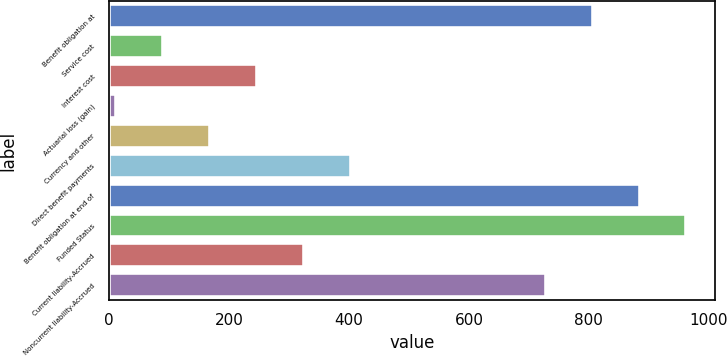Convert chart. <chart><loc_0><loc_0><loc_500><loc_500><bar_chart><fcel>Benefit obligation at<fcel>Service cost<fcel>Interest cost<fcel>Actuarial loss (gain)<fcel>Currency and other<fcel>Direct benefit payments<fcel>Benefit obligation at end of<fcel>Funded Status<fcel>Current liability-Accrued<fcel>Noncurrent liability-Accrued<nl><fcel>806.3<fcel>90.3<fcel>246.9<fcel>12<fcel>168.6<fcel>403.5<fcel>884.6<fcel>962.9<fcel>325.2<fcel>728<nl></chart> 